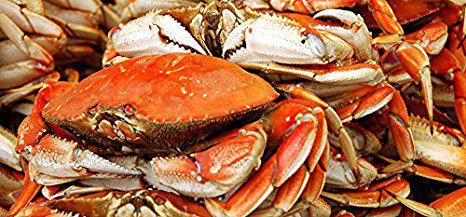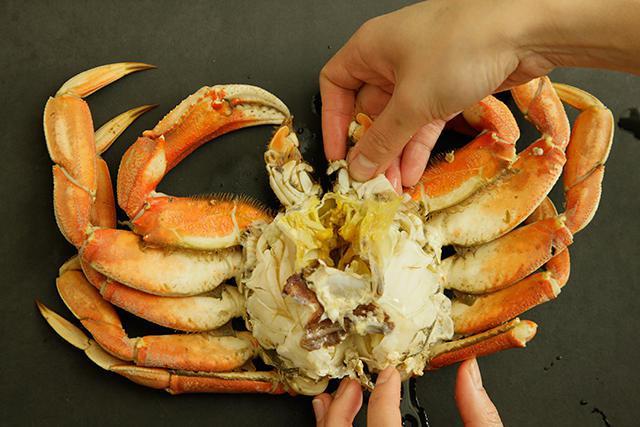The first image is the image on the left, the second image is the image on the right. Assess this claim about the two images: "In the image on the right, a person is pulling apart the crab to expose its meat.". Correct or not? Answer yes or no. Yes. The first image is the image on the left, the second image is the image on the right. Evaluate the accuracy of this statement regarding the images: "Atleast one image of a crab split down the middle.". Is it true? Answer yes or no. Yes. 